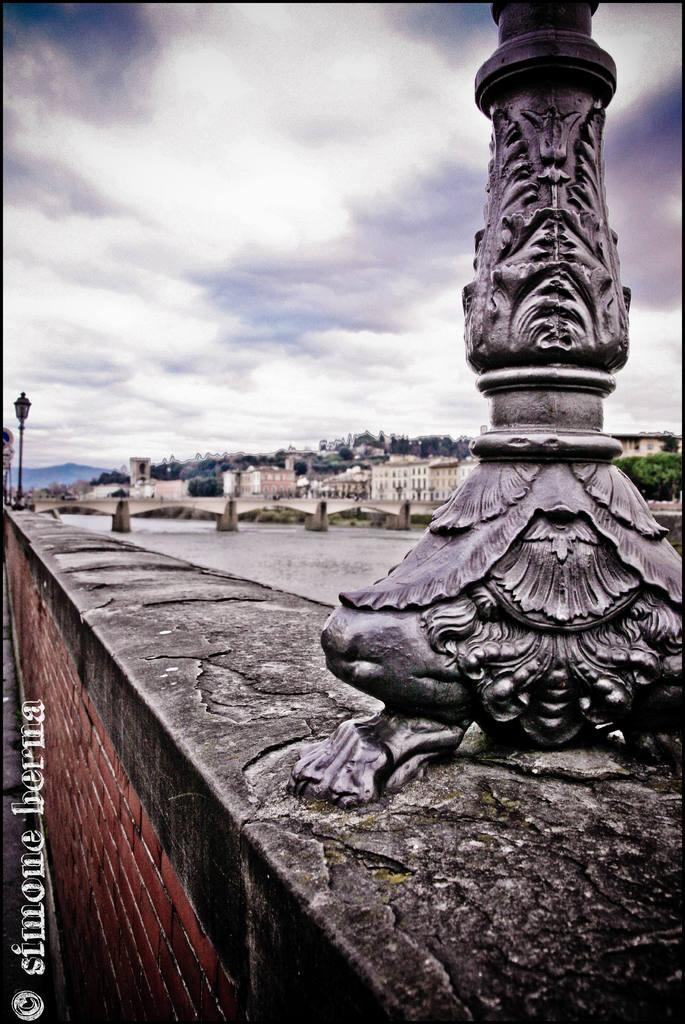What is the main object in the foreground of the image? There is a pole in the image. What can be seen in the background of the image? Water, a bridge, buildings, and trees with green color are visible in the background of the image. What is the color of the sky in the image? The sky is blue and white in color. What type of writing can be seen on the pole in the image? There is no writing visible on the pole in the image. What force is being applied to the bridge in the image? There is no indication of any force being applied to the bridge in the image. Is there any pain or discomfort visible on the trees in the image? There is no indication of pain or discomfort on the trees in the image. 